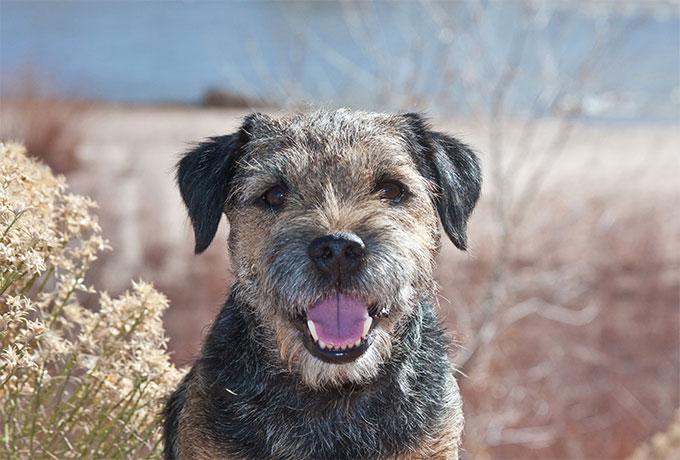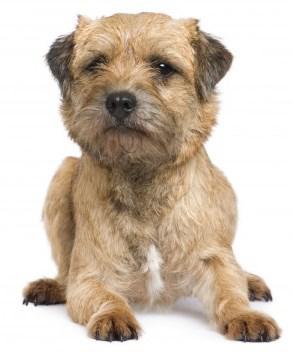The first image is the image on the left, the second image is the image on the right. Analyze the images presented: Is the assertion "Left image shows one upright dog looking slightly downward and rightward." valid? Answer yes or no. No. The first image is the image on the left, the second image is the image on the right. Evaluate the accuracy of this statement regarding the images: "A dog is wearing a collar.". Is it true? Answer yes or no. No. 